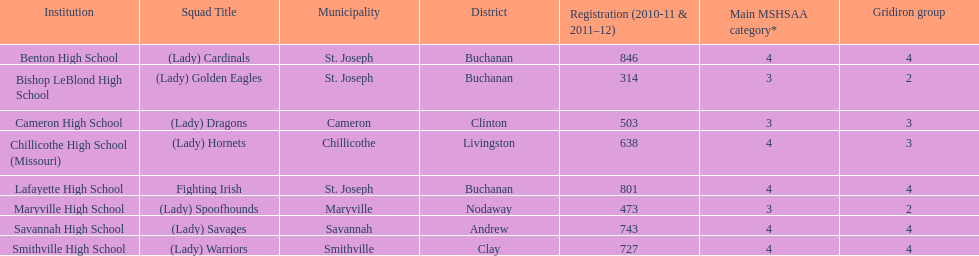What is the number of football classes lafayette high school has? 4. 